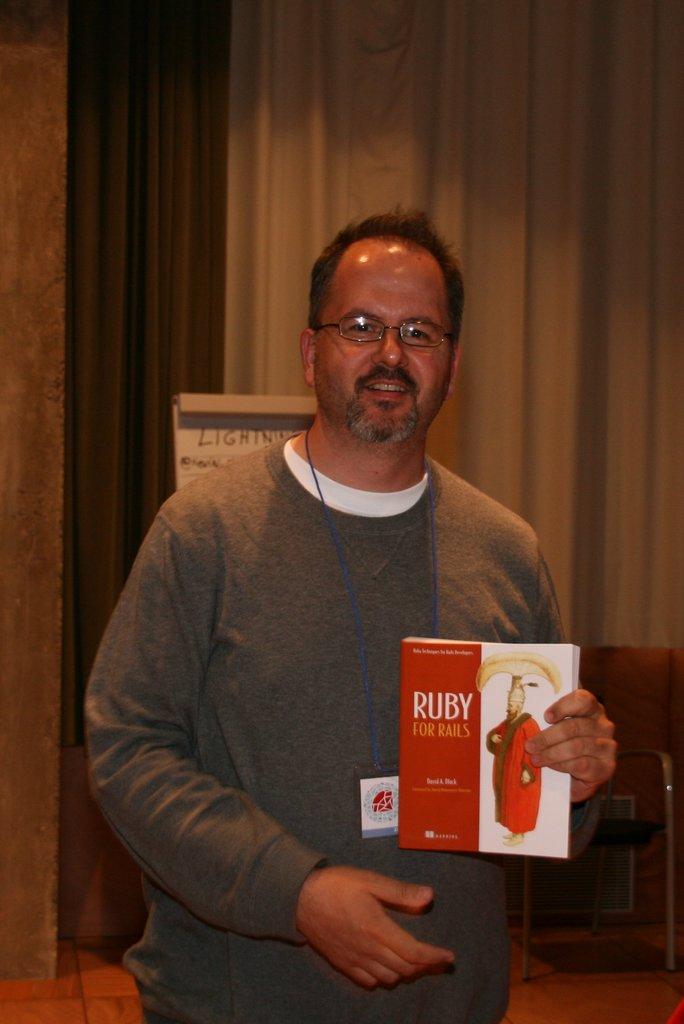What is the first word of the title of the book?
Ensure brevity in your answer.  Ruby. 